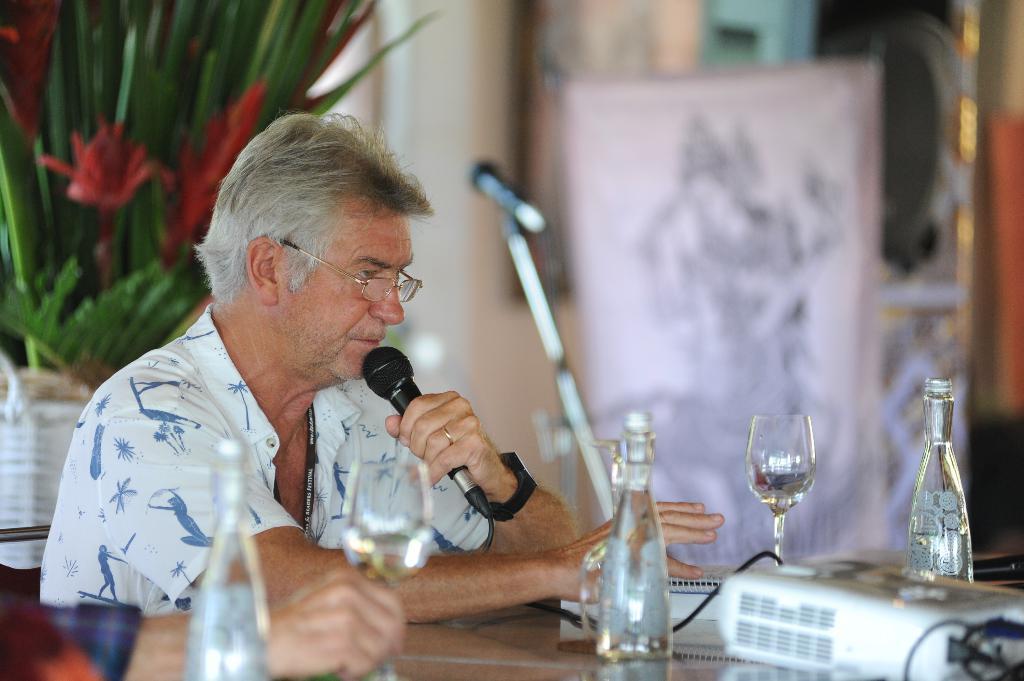In one or two sentences, can you explain what this image depicts? In this image we can see there is a person holding mic, in front of him we can see there are bottles, glasses, projector and few objects. Left side, we can see the person's hand and plant with flowers. And we can see a microphone and blur background. 